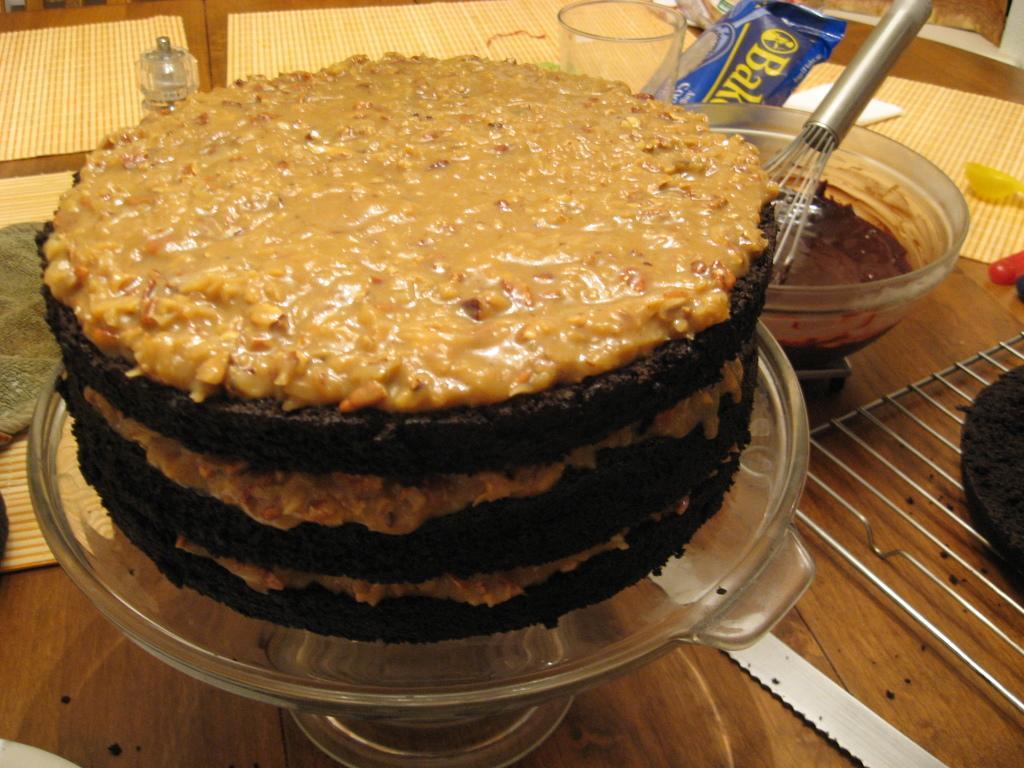Can you describe this image briefly? In this picture I see a cake in front which is on this glass thing and side to this cake I see a bowl and a thing in it and I see a wrapper side to this bowl and I see a glass and all these things are on a table. 